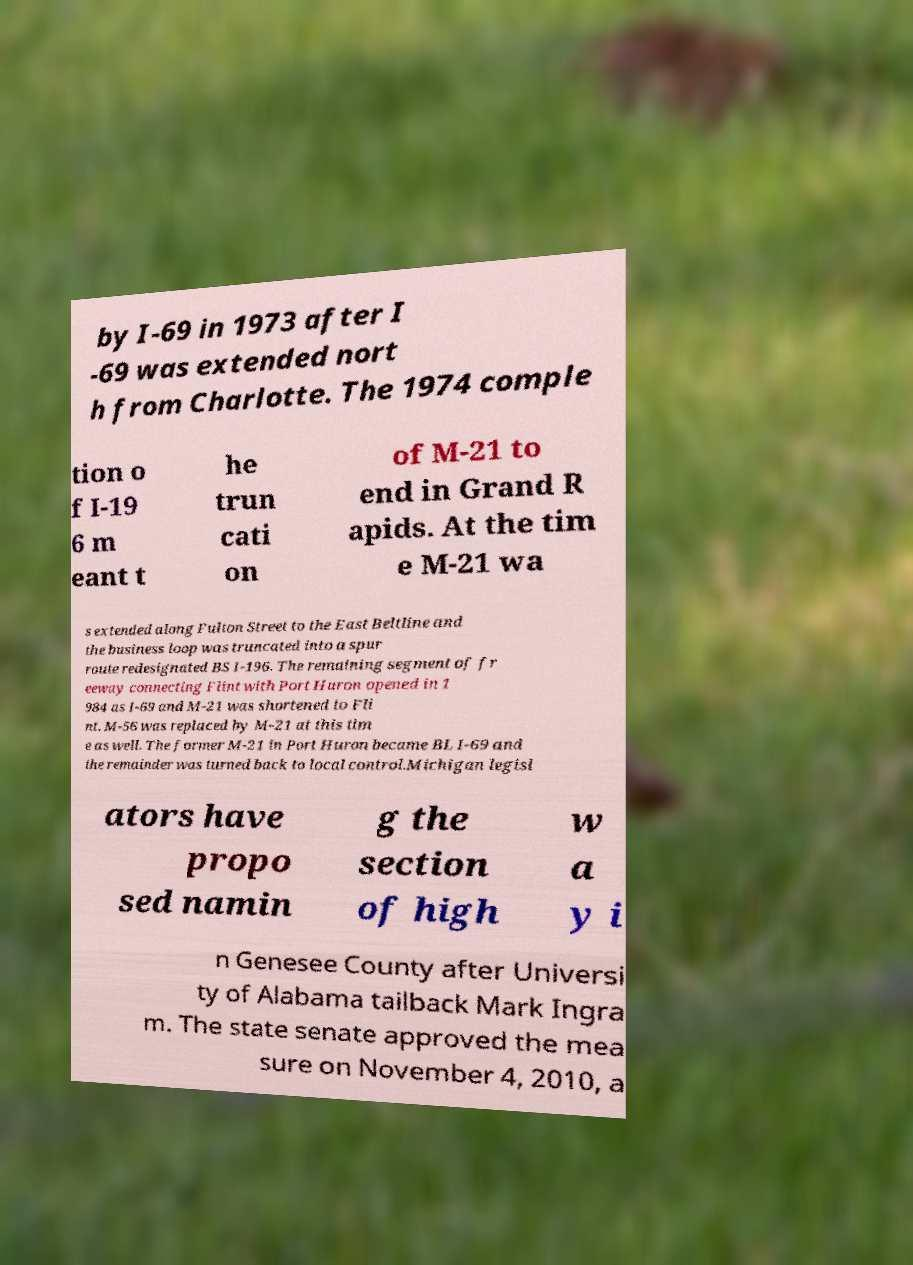Could you extract and type out the text from this image? by I-69 in 1973 after I -69 was extended nort h from Charlotte. The 1974 comple tion o f I-19 6 m eant t he trun cati on of M-21 to end in Grand R apids. At the tim e M-21 wa s extended along Fulton Street to the East Beltline and the business loop was truncated into a spur route redesignated BS I-196. The remaining segment of fr eeway connecting Flint with Port Huron opened in 1 984 as I-69 and M-21 was shortened to Fli nt. M-56 was replaced by M-21 at this tim e as well. The former M-21 in Port Huron became BL I-69 and the remainder was turned back to local control.Michigan legisl ators have propo sed namin g the section of high w a y i n Genesee County after Universi ty of Alabama tailback Mark Ingra m. The state senate approved the mea sure on November 4, 2010, a 